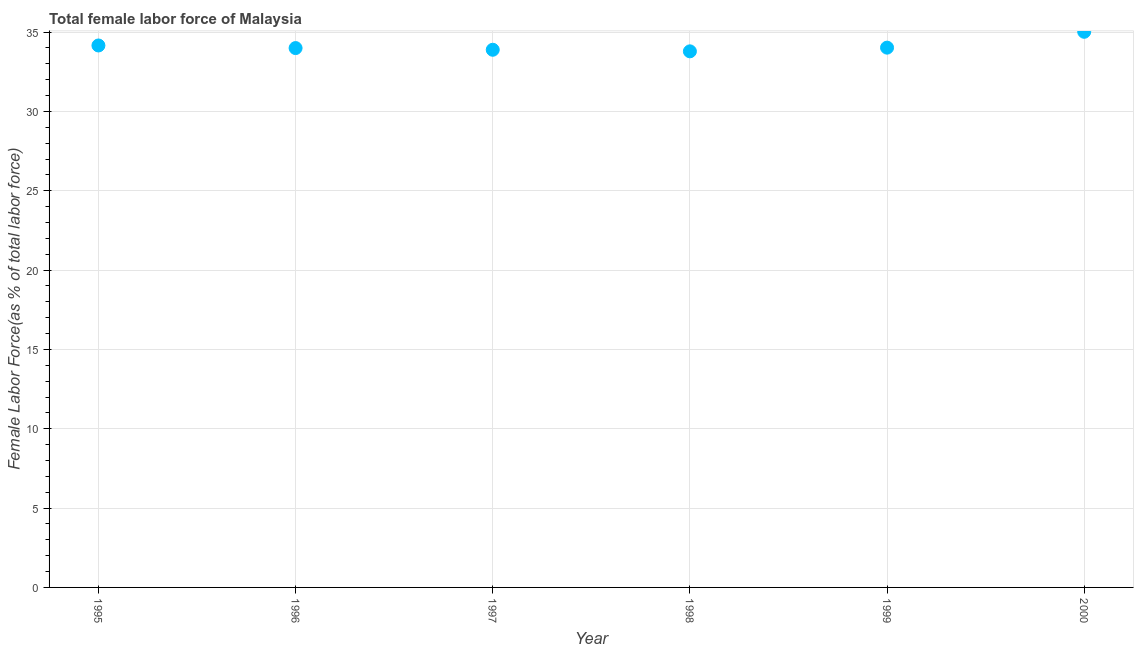What is the total female labor force in 1999?
Offer a very short reply. 34.02. Across all years, what is the maximum total female labor force?
Make the answer very short. 35.02. Across all years, what is the minimum total female labor force?
Make the answer very short. 33.79. In which year was the total female labor force minimum?
Provide a succinct answer. 1998. What is the sum of the total female labor force?
Your answer should be compact. 204.87. What is the difference between the total female labor force in 1999 and 2000?
Offer a terse response. -1. What is the average total female labor force per year?
Ensure brevity in your answer.  34.15. What is the median total female labor force?
Your answer should be very brief. 34.01. Do a majority of the years between 1997 and 1996 (inclusive) have total female labor force greater than 14 %?
Offer a terse response. No. What is the ratio of the total female labor force in 1998 to that in 1999?
Ensure brevity in your answer.  0.99. What is the difference between the highest and the second highest total female labor force?
Provide a succinct answer. 0.86. What is the difference between the highest and the lowest total female labor force?
Give a very brief answer. 1.23. How many years are there in the graph?
Provide a succinct answer. 6. Does the graph contain grids?
Offer a very short reply. Yes. What is the title of the graph?
Give a very brief answer. Total female labor force of Malaysia. What is the label or title of the Y-axis?
Provide a succinct answer. Female Labor Force(as % of total labor force). What is the Female Labor Force(as % of total labor force) in 1995?
Your answer should be compact. 34.16. What is the Female Labor Force(as % of total labor force) in 1996?
Give a very brief answer. 33.99. What is the Female Labor Force(as % of total labor force) in 1997?
Give a very brief answer. 33.89. What is the Female Labor Force(as % of total labor force) in 1998?
Offer a very short reply. 33.79. What is the Female Labor Force(as % of total labor force) in 1999?
Your answer should be very brief. 34.02. What is the Female Labor Force(as % of total labor force) in 2000?
Provide a succinct answer. 35.02. What is the difference between the Female Labor Force(as % of total labor force) in 1995 and 1996?
Your response must be concise. 0.16. What is the difference between the Female Labor Force(as % of total labor force) in 1995 and 1997?
Provide a short and direct response. 0.27. What is the difference between the Female Labor Force(as % of total labor force) in 1995 and 1998?
Provide a short and direct response. 0.37. What is the difference between the Female Labor Force(as % of total labor force) in 1995 and 1999?
Offer a terse response. 0.14. What is the difference between the Female Labor Force(as % of total labor force) in 1995 and 2000?
Ensure brevity in your answer.  -0.86. What is the difference between the Female Labor Force(as % of total labor force) in 1996 and 1997?
Your response must be concise. 0.11. What is the difference between the Female Labor Force(as % of total labor force) in 1996 and 1998?
Your response must be concise. 0.21. What is the difference between the Female Labor Force(as % of total labor force) in 1996 and 1999?
Provide a succinct answer. -0.03. What is the difference between the Female Labor Force(as % of total labor force) in 1996 and 2000?
Give a very brief answer. -1.03. What is the difference between the Female Labor Force(as % of total labor force) in 1997 and 1998?
Your answer should be compact. 0.1. What is the difference between the Female Labor Force(as % of total labor force) in 1997 and 1999?
Make the answer very short. -0.13. What is the difference between the Female Labor Force(as % of total labor force) in 1997 and 2000?
Your response must be concise. -1.13. What is the difference between the Female Labor Force(as % of total labor force) in 1998 and 1999?
Your response must be concise. -0.23. What is the difference between the Female Labor Force(as % of total labor force) in 1998 and 2000?
Make the answer very short. -1.23. What is the difference between the Female Labor Force(as % of total labor force) in 1999 and 2000?
Your answer should be compact. -1. What is the ratio of the Female Labor Force(as % of total labor force) in 1995 to that in 1997?
Offer a very short reply. 1.01. What is the ratio of the Female Labor Force(as % of total labor force) in 1996 to that in 1997?
Provide a short and direct response. 1. What is the ratio of the Female Labor Force(as % of total labor force) in 1996 to that in 1998?
Your answer should be compact. 1.01. What is the ratio of the Female Labor Force(as % of total labor force) in 1996 to that in 2000?
Offer a terse response. 0.97. What is the ratio of the Female Labor Force(as % of total labor force) in 1997 to that in 1999?
Your answer should be very brief. 1. What is the ratio of the Female Labor Force(as % of total labor force) in 1997 to that in 2000?
Ensure brevity in your answer.  0.97. What is the ratio of the Female Labor Force(as % of total labor force) in 1998 to that in 2000?
Your response must be concise. 0.96. 